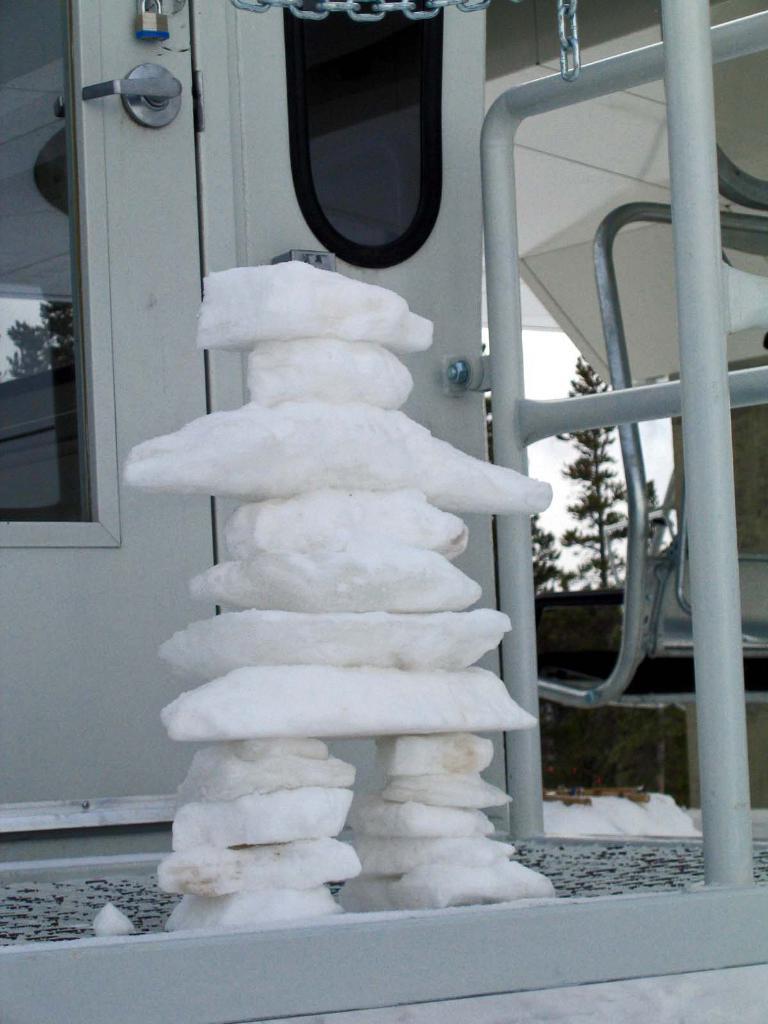Can you describe this image briefly? In this image we can see stones arranged into a structure. In the background we can see lock, door with a handle, chain, grill, trees, floor and sky. 